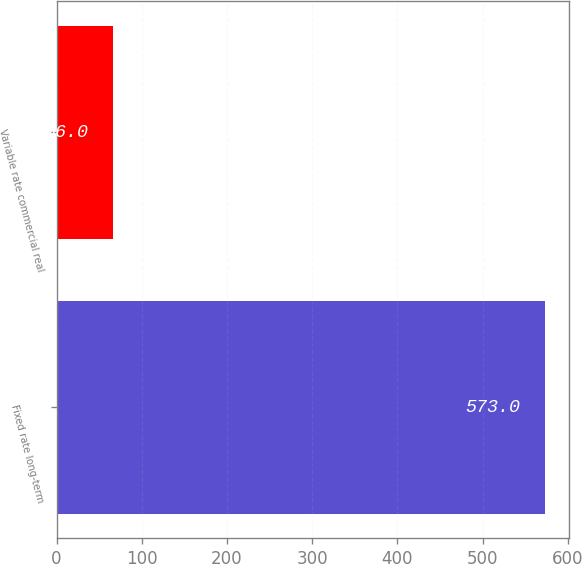<chart> <loc_0><loc_0><loc_500><loc_500><bar_chart><fcel>Fixed rate long-term<fcel>Variable rate commercial real<nl><fcel>573<fcel>66<nl></chart> 